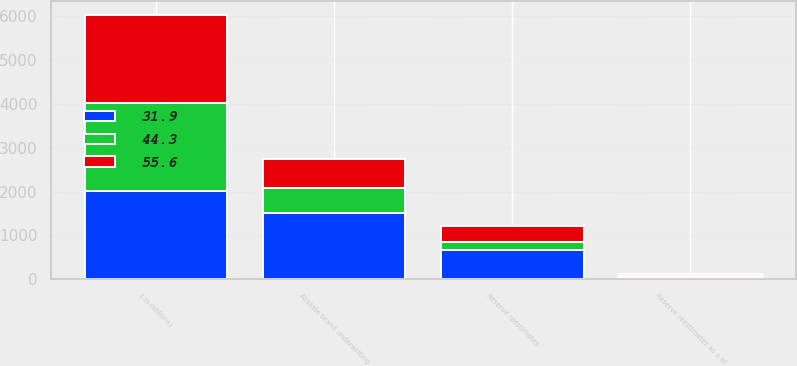<chart> <loc_0><loc_0><loc_500><loc_500><stacked_bar_chart><ecel><fcel>( in millions)<fcel>Reserve reestimates<fcel>Allstate brand underwriting<fcel>Reserve reestimates as a of<nl><fcel>31.9<fcel>2012<fcel>671<fcel>1515<fcel>44.3<nl><fcel>55.6<fcel>2011<fcel>371<fcel>667<fcel>55.6<nl><fcel>44.3<fcel>2010<fcel>181<fcel>568<fcel>31.9<nl></chart> 